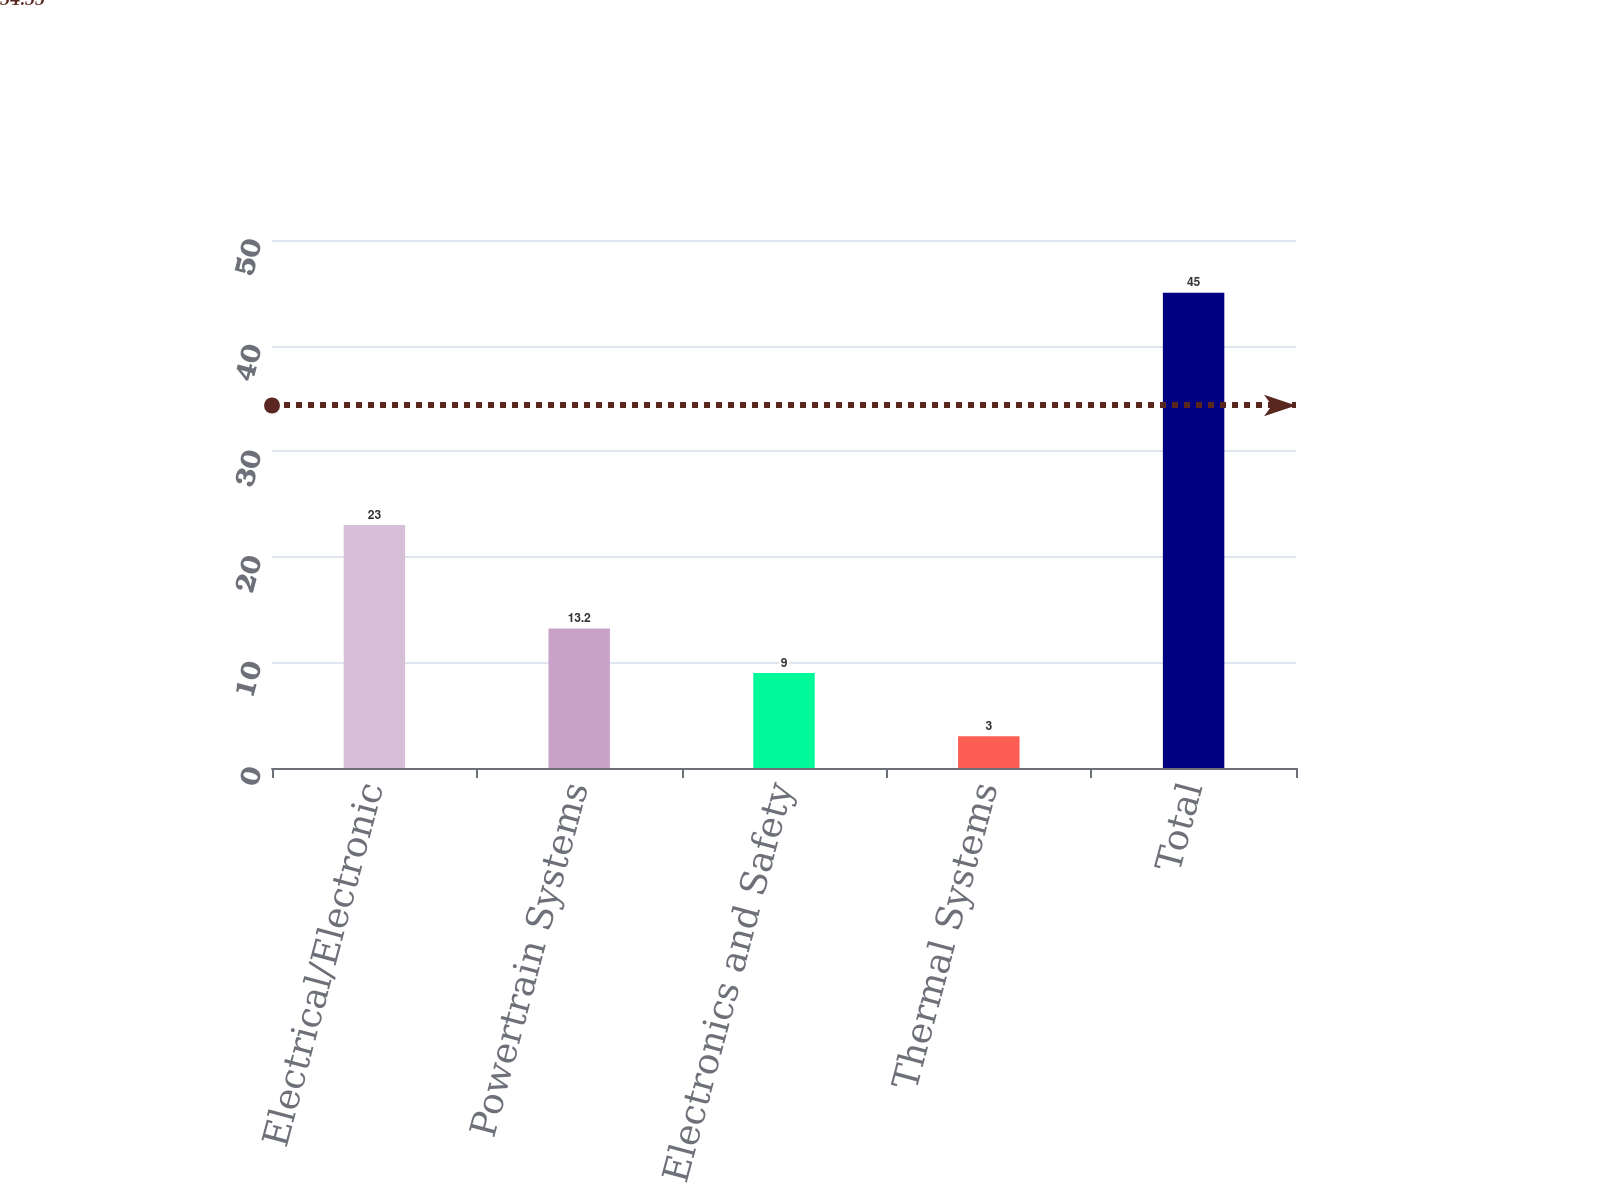Convert chart to OTSL. <chart><loc_0><loc_0><loc_500><loc_500><bar_chart><fcel>Electrical/Electronic<fcel>Powertrain Systems<fcel>Electronics and Safety<fcel>Thermal Systems<fcel>Total<nl><fcel>23<fcel>13.2<fcel>9<fcel>3<fcel>45<nl></chart> 